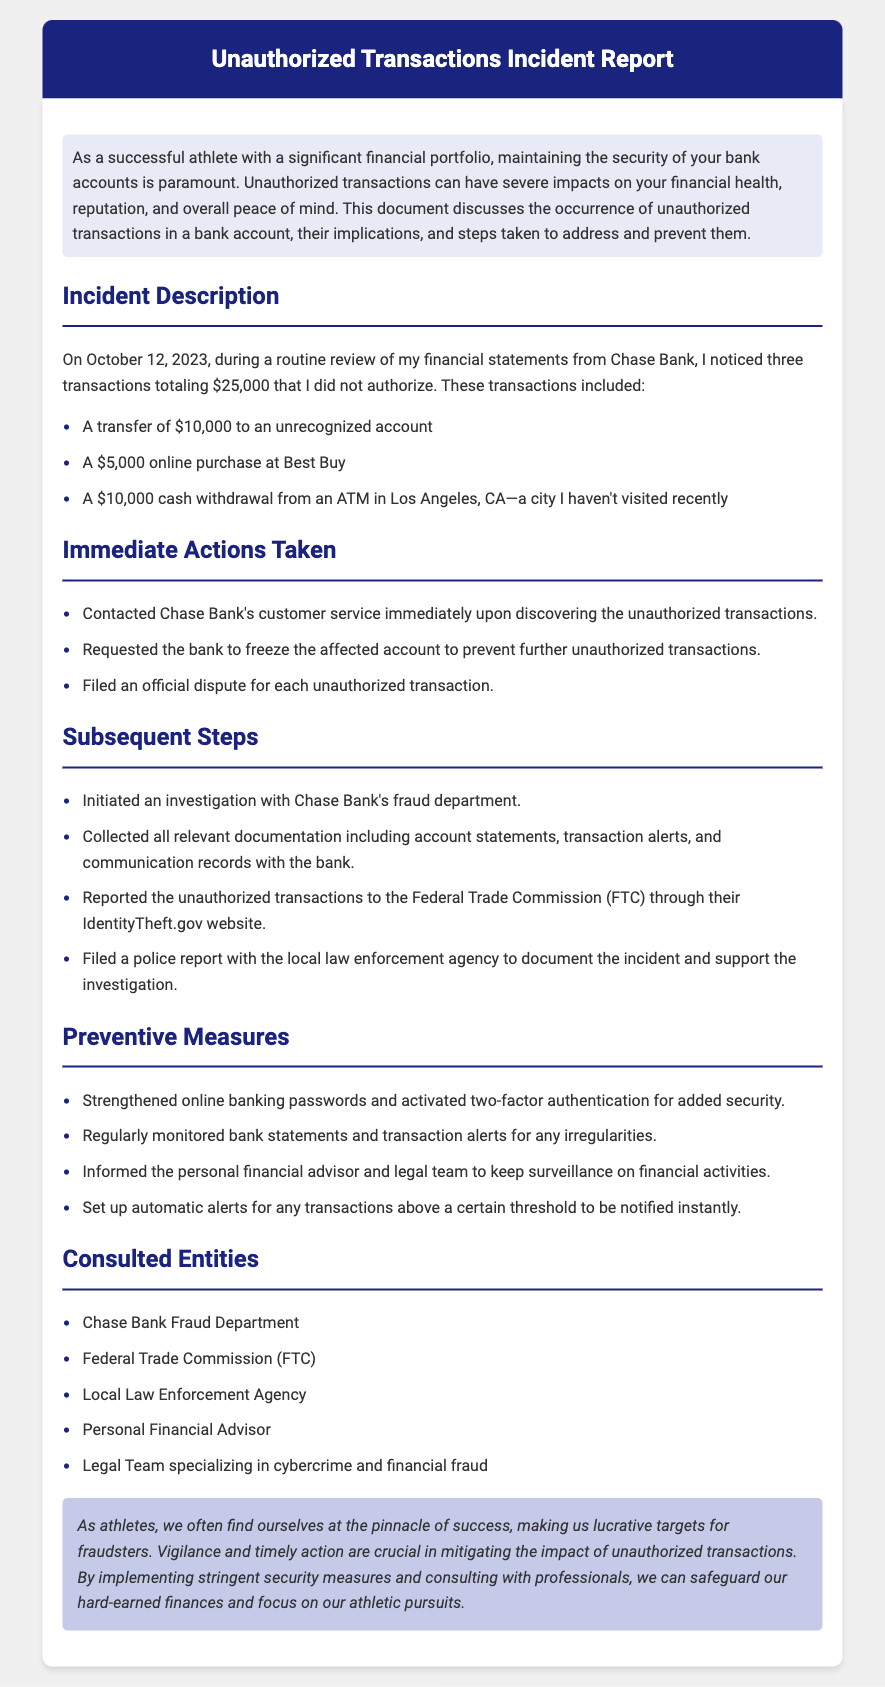What date did the incident occur? The incident occurred on October 12, 2023, which is explicitly mentioned in the document.
Answer: October 12, 2023 How much total money was involved in the unauthorized transactions? The document lists the amounts of the unauthorized transactions which total $25,000 when combined.
Answer: $25,000 What was the amount of the cash withdrawal? The document states there was a $10,000 cash withdrawal from an ATM.
Answer: $10,000 Which bank was contacted regarding the unauthorized transactions? The document mentions Chase Bank as the bank involved in the incident.
Answer: Chase Bank What measure was taken to prevent further unauthorized transactions? The document specifies that the affected account was frozen to prevent unauthorized transactions.
Answer: Frozen account How many entities were consulted regarding the incident? The document lists five entities that were consulted which includes the fraud department and others.
Answer: Five What type of crime was reported to the local law enforcement agency? The document indicates that unauthorized transactions, related to fraud, were reported to law enforcement.
Answer: Fraud What security feature was activated for online banking? The document states that two-factor authentication was activated for added security.
Answer: Two-factor authentication What was filed with the Federal Trade Commission? The document refers to the filing of a report regarding the unauthorized transactions with the FTC.
Answer: A report 